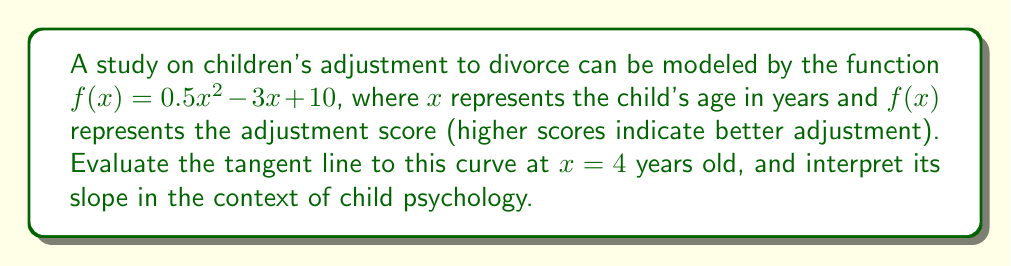Can you solve this math problem? To find the tangent line, we need to:
1. Calculate $f(4)$ to get the y-coordinate of the point of tangency.
2. Find $f'(x)$ to get the general derivative function.
3. Calculate $f'(4)$ to get the slope of the tangent line at $x = 4$.
4. Use the point-slope form of a line to write the equation of the tangent line.

Step 1: Calculate $f(4)$
$$f(4) = 0.5(4)^2 - 3(4) + 10 = 0.5(16) - 12 + 10 = 8 - 12 + 10 = 6$$

Step 2: Find $f'(x)$
$$f'(x) = \frac{d}{dx}(0.5x^2 - 3x + 10) = x - 3$$

Step 3: Calculate $f'(4)$
$$f'(4) = 4 - 3 = 1$$

Step 4: Write the equation of the tangent line
Using the point-slope form $y - y_1 = m(x - x_1)$, where $(x_1, y_1) = (4, 6)$ and $m = 1$:
$$y - 6 = 1(x - 4)$$
$$y = x - 4 + 6$$
$$y = x + 2$$

Interpretation: The slope of the tangent line is 1, which means that at age 4, the child's adjustment score is increasing at a rate of 1 point per year. This suggests that around this age, children are showing a steady improvement in their ability to adjust to their parents' divorce.
Answer: $y = x + 2$; slope = 1 (adjustment score increases by 1 point per year at age 4) 